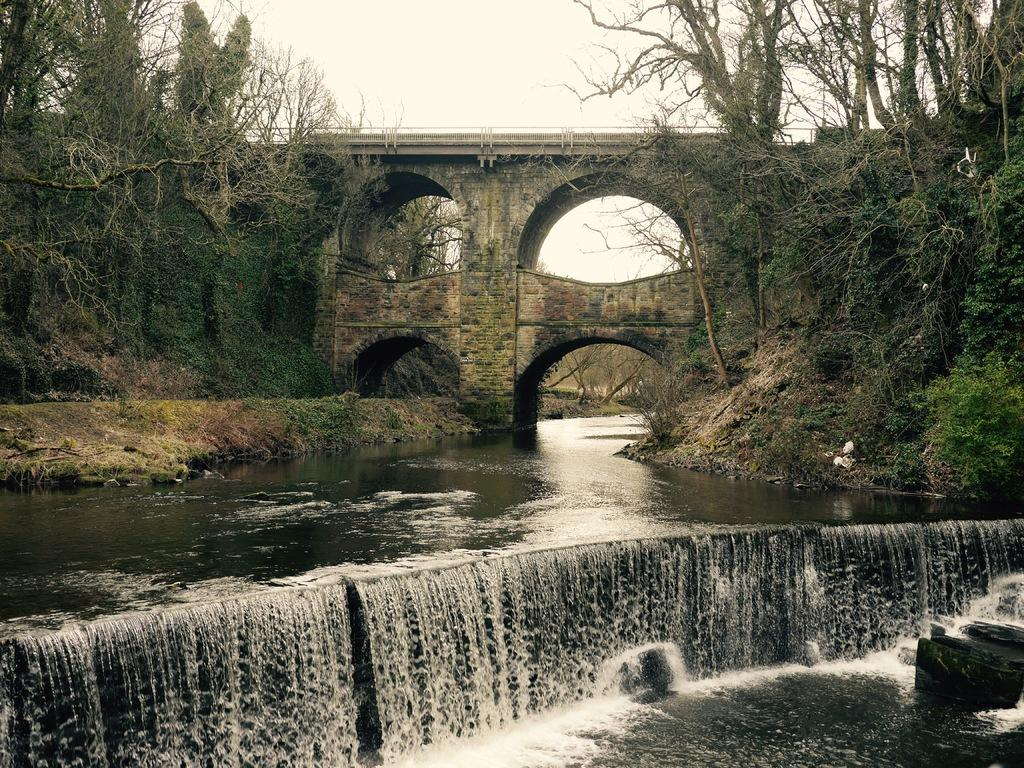What type of bridge is in the image? There is an arch bridge in the image. What is the bridge spanning or crossing over? The image does not provide information about what the bridge is spanning or crossing over. What else can be seen in the image besides the bridge? There is water visible in the image, as well as trees. What is visible at the top of the image? The sky is visible at the top of the image. How many brothers are depicted in the image? There are no people, let alone brothers, present in the image. 